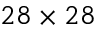Convert formula to latex. <formula><loc_0><loc_0><loc_500><loc_500>2 8 \times 2 8</formula> 